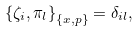Convert formula to latex. <formula><loc_0><loc_0><loc_500><loc_500>\left \{ \zeta _ { i } , \pi _ { l } \right \} _ { \left \{ x , p \right \} } = \delta _ { i l } ,</formula> 